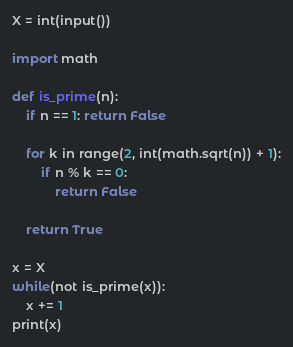Convert code to text. <code><loc_0><loc_0><loc_500><loc_500><_Python_>X = int(input())

import math

def is_prime(n):
    if n == 1: return False

    for k in range(2, int(math.sqrt(n)) + 1):
        if n % k == 0:
            return False

    return True

x = X
while(not is_prime(x)):
    x += 1
print(x)</code> 